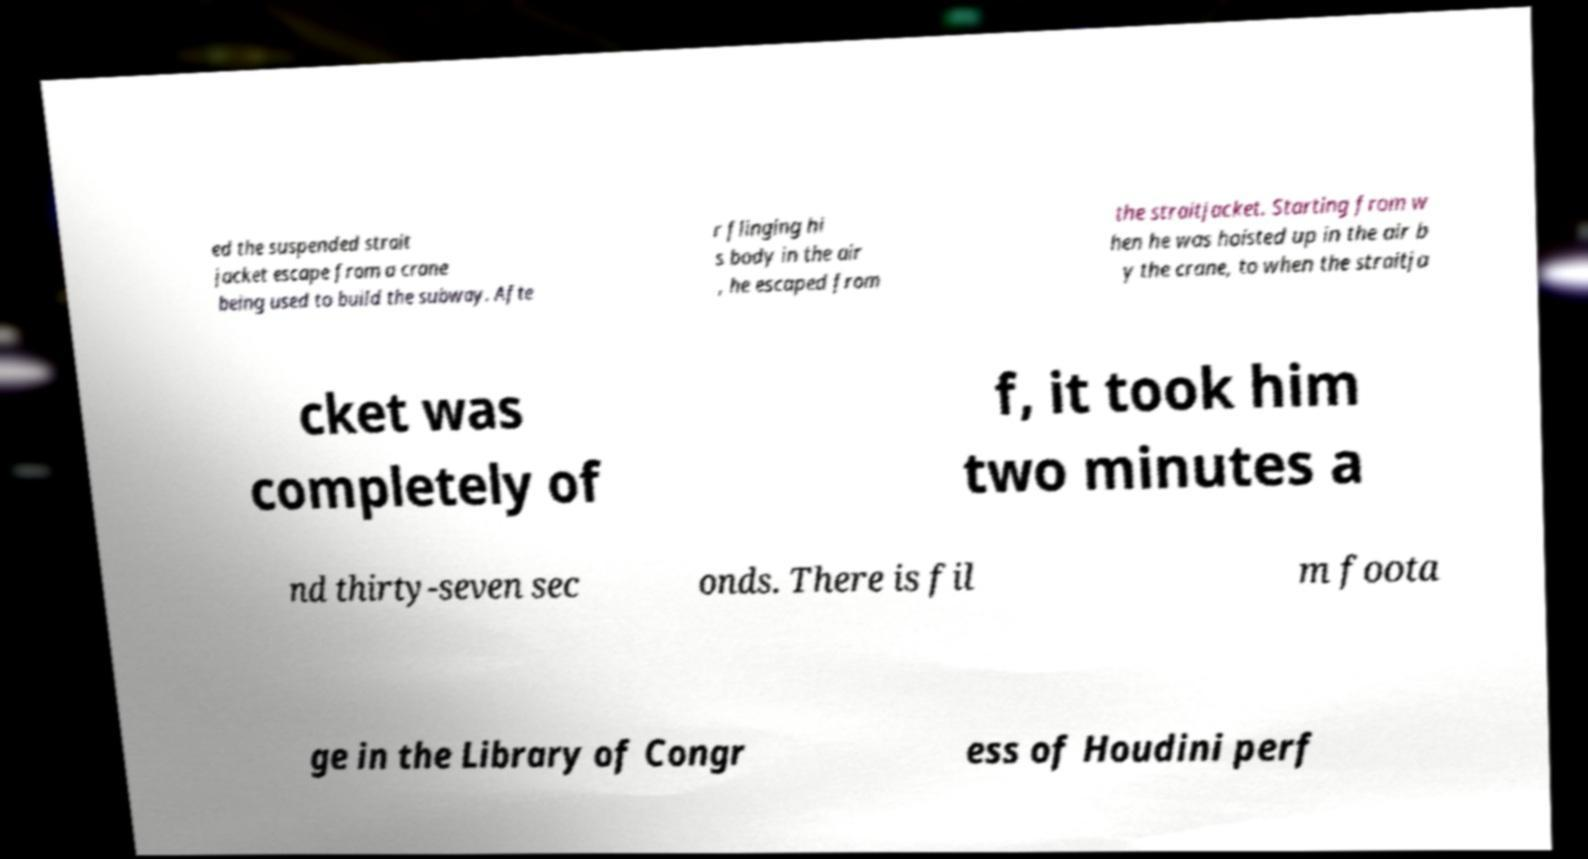For documentation purposes, I need the text within this image transcribed. Could you provide that? ed the suspended strait jacket escape from a crane being used to build the subway. Afte r flinging hi s body in the air , he escaped from the straitjacket. Starting from w hen he was hoisted up in the air b y the crane, to when the straitja cket was completely of f, it took him two minutes a nd thirty-seven sec onds. There is fil m foota ge in the Library of Congr ess of Houdini perf 